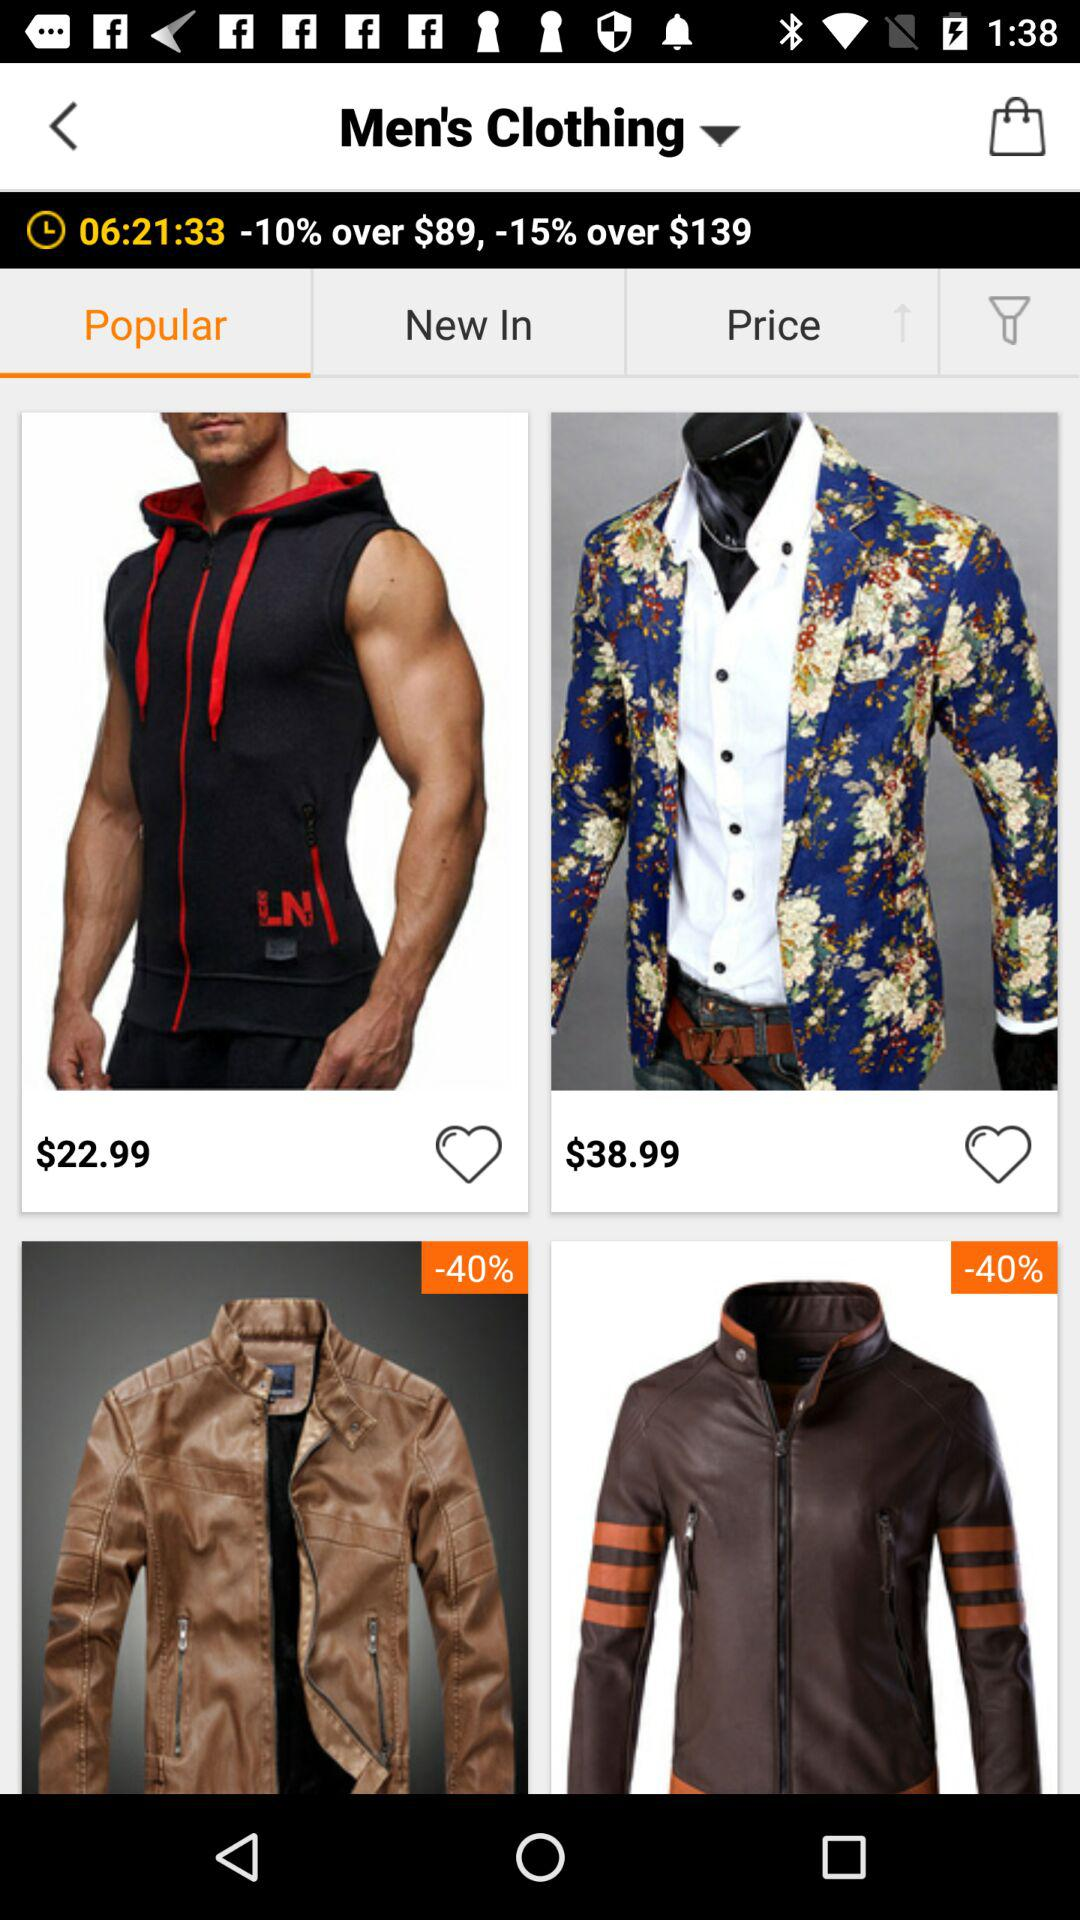Which tab is selected? The selected tab is "Popular". 